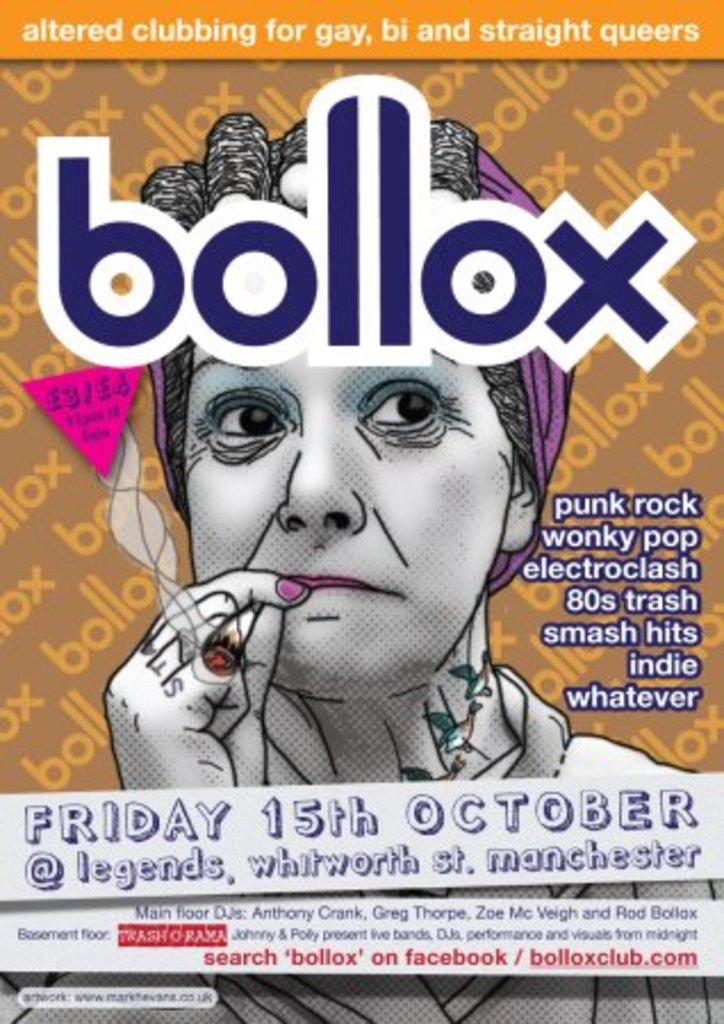<image>
Give a short and clear explanation of the subsequent image. A poster with a woman smoking on it advertises an event called Bollox. 